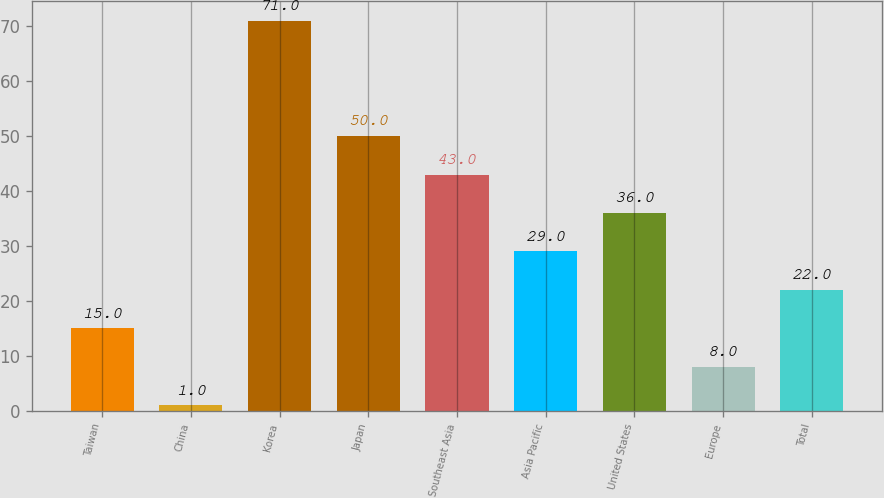Convert chart. <chart><loc_0><loc_0><loc_500><loc_500><bar_chart><fcel>Taiwan<fcel>China<fcel>Korea<fcel>Japan<fcel>Southeast Asia<fcel>Asia Pacific<fcel>United States<fcel>Europe<fcel>Total<nl><fcel>15<fcel>1<fcel>71<fcel>50<fcel>43<fcel>29<fcel>36<fcel>8<fcel>22<nl></chart> 